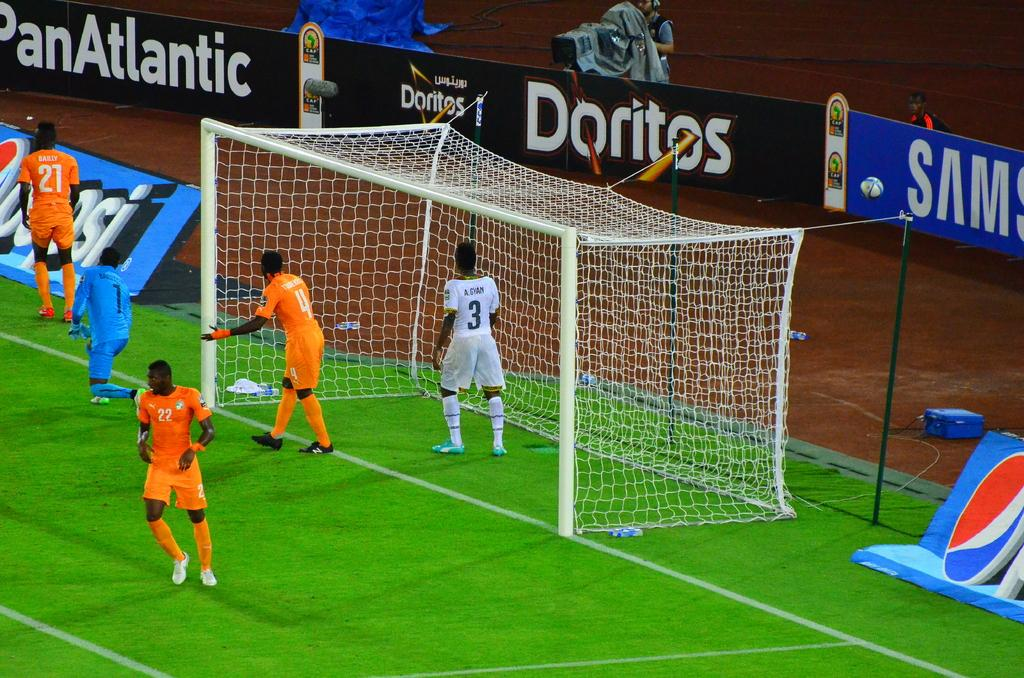<image>
Describe the image concisely. a sign the has the brand Doritos on it 